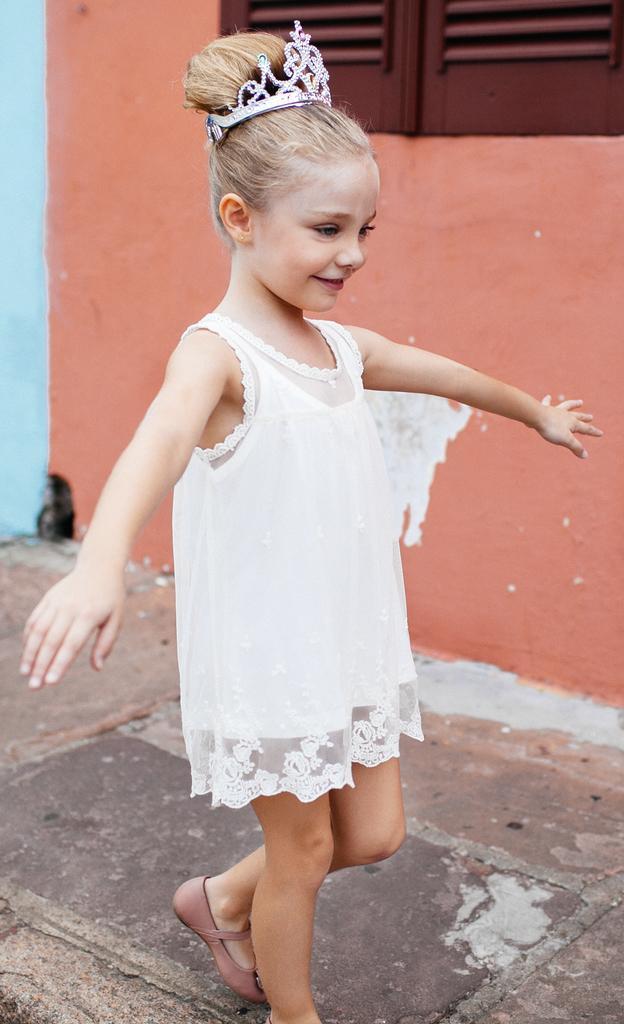Could you give a brief overview of what you see in this image? In this image we can see a girl is standing, she is wearing white color dress and crown on head. Behind orange color wall is present with wooden window. 